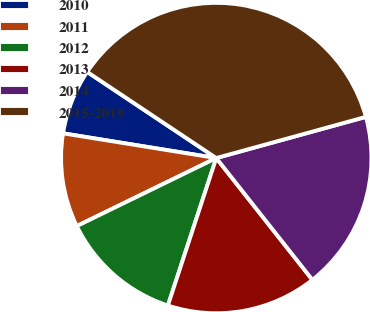<chart> <loc_0><loc_0><loc_500><loc_500><pie_chart><fcel>2010<fcel>2011<fcel>2012<fcel>2013<fcel>2014<fcel>2015-2019<nl><fcel>6.82%<fcel>9.77%<fcel>12.73%<fcel>15.68%<fcel>18.64%<fcel>36.36%<nl></chart> 